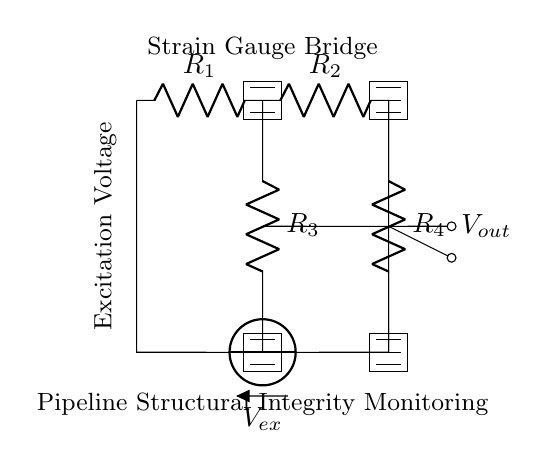What are the resistors labeled in the circuit? The resistors in the circuit are labeled as R1, R2, R3, and R4. Each resistor has its own designated label, clearly visible in the circuit diagram.
Answer: R1, R2, R3, R4 What is the function of the voltage source in this circuit? The voltage source labeled Vex provides the excitation voltage necessary for the strain gauge bridge to operate and produce a measurable output.
Answer: Provides excitation voltage What type of bridge circuit is represented here? This circuit represents a strain gauge bridge circuit specifically designed for measuring structural integrity, commonly used in applications like pipeline monitoring.
Answer: Strain gauge bridge Which components generate the output voltage in this circuit? The output voltage, Vout, is generated based on the resistance changes in the strain gauges represented by R1, R2, R3, and R4, which form the differential measurement part of the bridge.
Answer: R1, R2, R3, R4 How is the output voltage related to the resistance changes in the strain gauges? The output voltage, Vout, is determined by the differential voltage created from the changes in resistance across the bridge formed by the strain gauges in response to strain. Specifically, it is given by the formula relating output voltage to the ratio of resistor values influenced by strain.
Answer: Ratio of resistance changes 